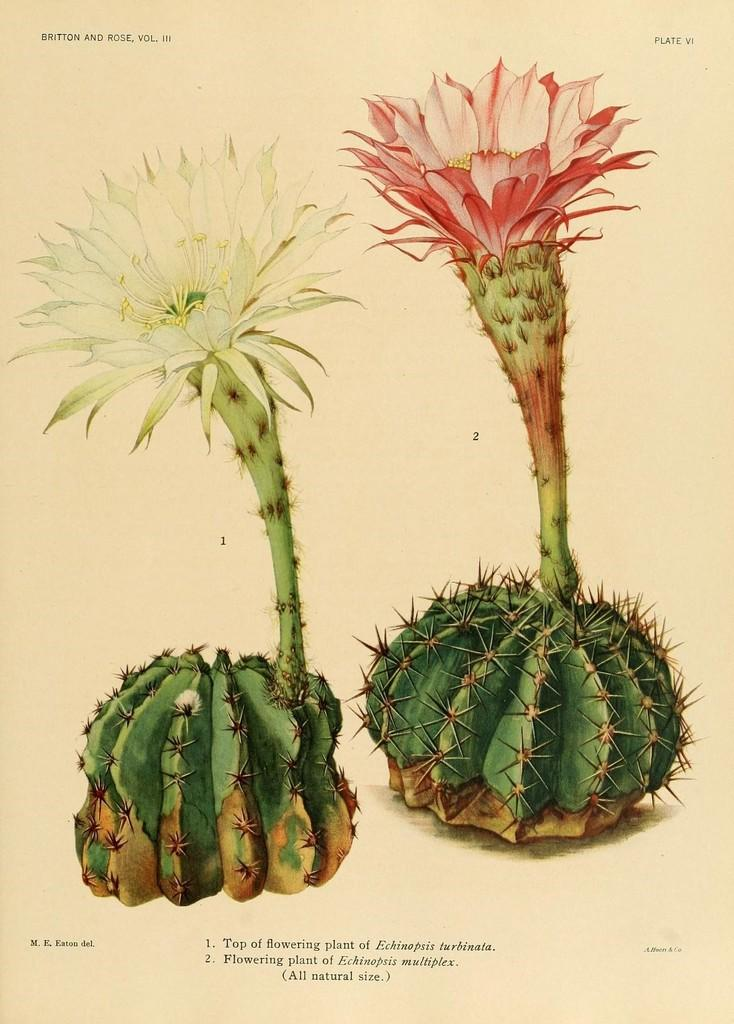What is present in the image that contains visual and written information? There is a poster in the image that contains images and text. Can you describe the content of the poster? The poster contains images and text, but the specific content cannot be determined from the provided facts. How many flowers are depicted on the poster in the image? There is no information about flowers on the poster, as the provided facts only mention that the poster contains images and text. 